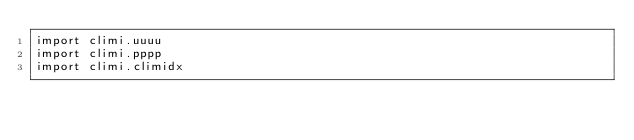<code> <loc_0><loc_0><loc_500><loc_500><_Python_>import climi.uuuu
import climi.pppp
import climi.climidx
</code> 